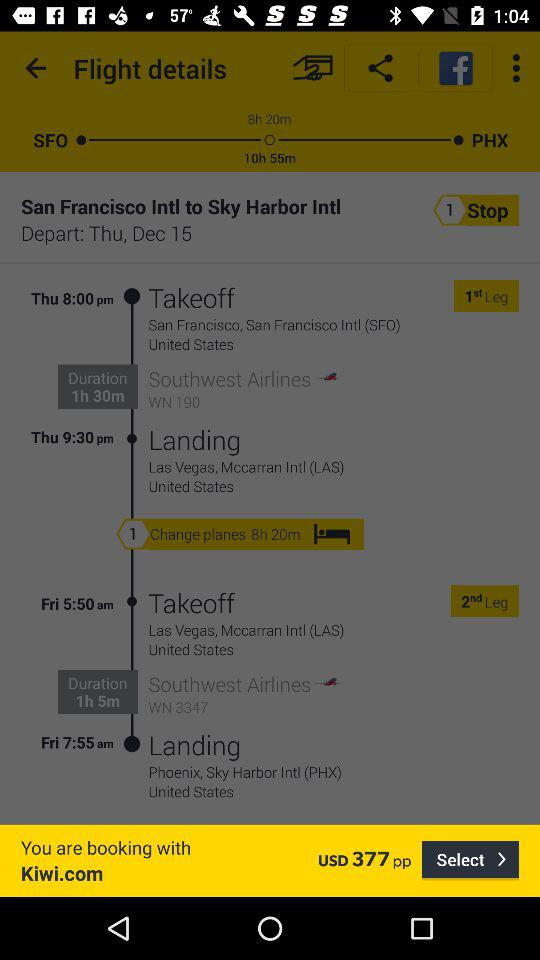How many hours is the total flight time?
Answer the question using a single word or phrase. 10h 55m 